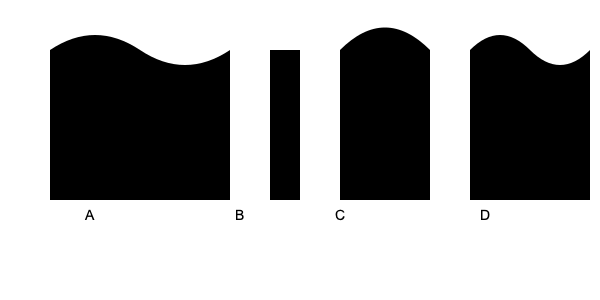As a musician familiar with various instruments, can you identify the musical instruments represented by the silhouettes labeled A, B, C, and D in the image above? To identify these musical instruments based on their silhouettes, let's analyze each shape:

1. Silhouette A:
   - Has a curved, wavy shape
   - Resembles the body of a string instrument
   - The curves suggest an hourglass figure typical of guitars or violins
   - Given its size and proportions, this is most likely an acoustic guitar

2. Silhouette B:
   - Has a straight, rectangular shape
   - Looks like a simple column or pillar
   - This straight design is characteristic of a piano key
   - The proportions match that of a single piano key

3. Silhouette C:
   - Features a rounded top and straight sides
   - The shape is reminiscent of a bell
   - This bell-like shape is typical of brass instruments
   - Given its size and proportions, this likely represents a trumpet

4. Silhouette D:
   - Has a curved top with a wider base
   - The shape suggests a wind instrument with a flared end
   - This profile is characteristic of a saxophone
   - The proportions and curve match that of an alto saxophone

Therefore, the instruments represented are:
A - Acoustic Guitar
B - Piano Key
C - Trumpet
D - Saxophone
Answer: A: Acoustic Guitar, B: Piano Key, C: Trumpet, D: Saxophone 